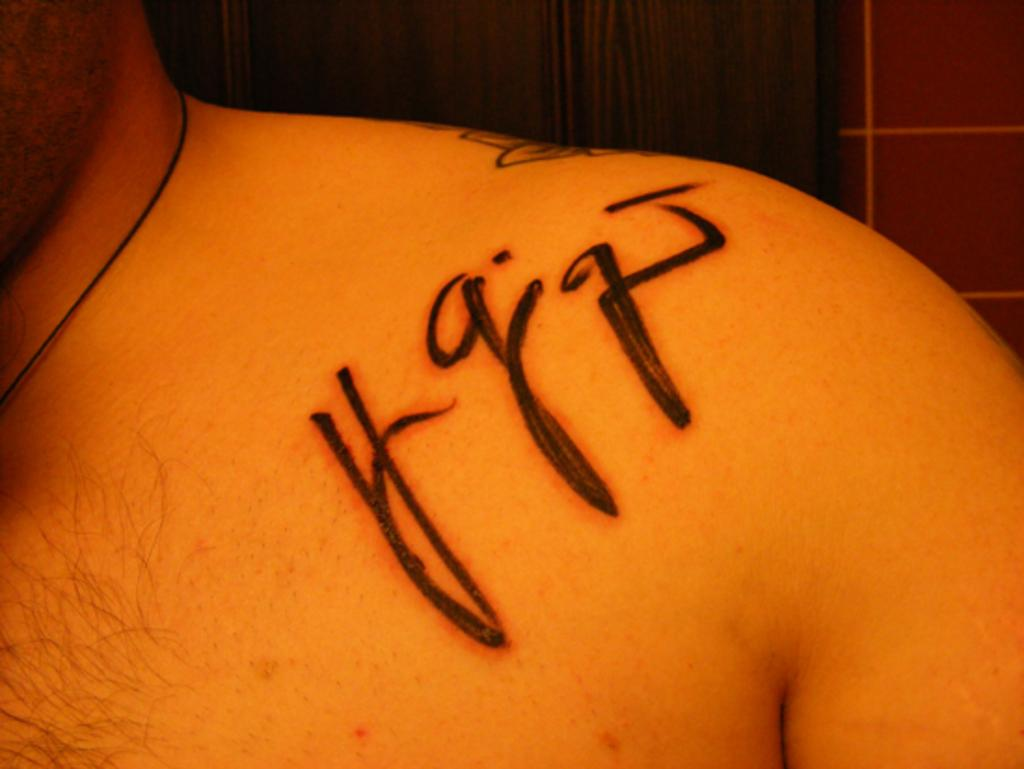What is the main subject of the image? There is a person in the image. Can you describe any distinguishing features of the person? The person has a tattoo. What is the color of the background in the image? The background of the image is brown in color. How does the person in the image turn into a bird? The person in the image does not turn into a bird, as there is no indication of any such transformation in the image. 